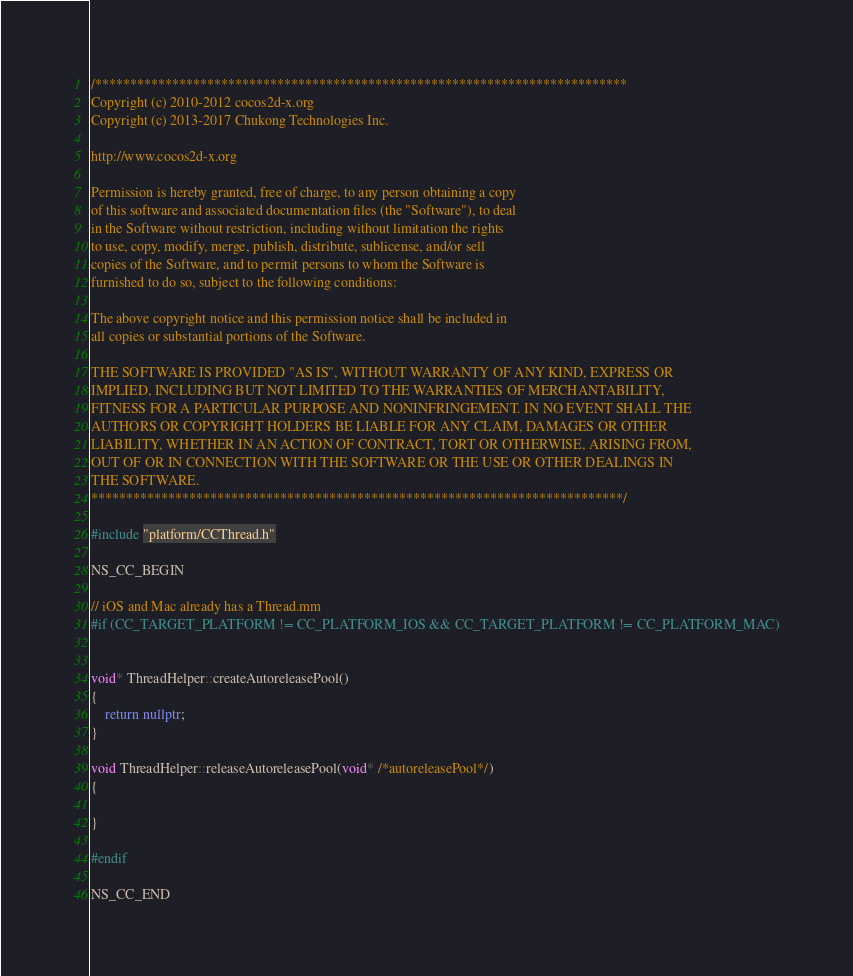<code> <loc_0><loc_0><loc_500><loc_500><_C++_>/****************************************************************************
Copyright (c) 2010-2012 cocos2d-x.org
Copyright (c) 2013-2017 Chukong Technologies Inc.

http://www.cocos2d-x.org

Permission is hereby granted, free of charge, to any person obtaining a copy
of this software and associated documentation files (the "Software"), to deal
in the Software without restriction, including without limitation the rights
to use, copy, modify, merge, publish, distribute, sublicense, and/or sell
copies of the Software, and to permit persons to whom the Software is
furnished to do so, subject to the following conditions:

The above copyright notice and this permission notice shall be included in
all copies or substantial portions of the Software.

THE SOFTWARE IS PROVIDED "AS IS", WITHOUT WARRANTY OF ANY KIND, EXPRESS OR
IMPLIED, INCLUDING BUT NOT LIMITED TO THE WARRANTIES OF MERCHANTABILITY,
FITNESS FOR A PARTICULAR PURPOSE AND NONINFRINGEMENT. IN NO EVENT SHALL THE
AUTHORS OR COPYRIGHT HOLDERS BE LIABLE FOR ANY CLAIM, DAMAGES OR OTHER
LIABILITY, WHETHER IN AN ACTION OF CONTRACT, TORT OR OTHERWISE, ARISING FROM,
OUT OF OR IN CONNECTION WITH THE SOFTWARE OR THE USE OR OTHER DEALINGS IN
THE SOFTWARE.
****************************************************************************/

#include "platform/CCThread.h"

NS_CC_BEGIN

// iOS and Mac already has a Thread.mm
#if (CC_TARGET_PLATFORM != CC_PLATFORM_IOS && CC_TARGET_PLATFORM != CC_PLATFORM_MAC)


void* ThreadHelper::createAutoreleasePool()
{
    return nullptr;
}

void ThreadHelper::releaseAutoreleasePool(void* /*autoreleasePool*/)
{
    
}

#endif

NS_CC_END
</code> 